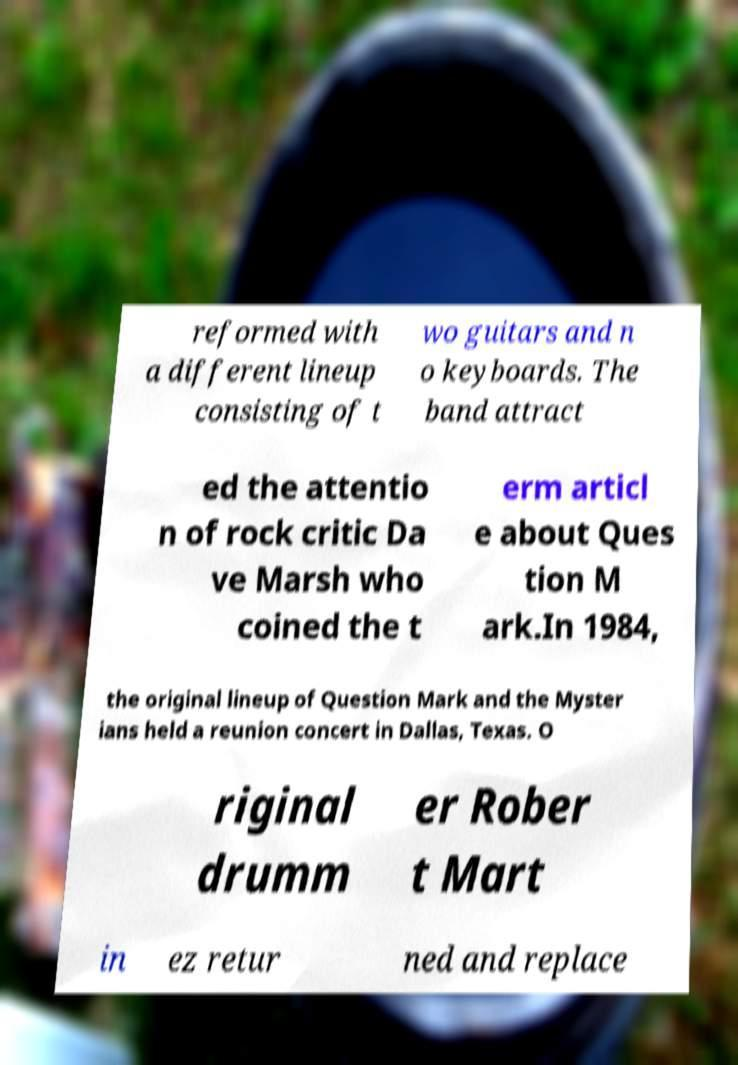I need the written content from this picture converted into text. Can you do that? reformed with a different lineup consisting of t wo guitars and n o keyboards. The band attract ed the attentio n of rock critic Da ve Marsh who coined the t erm articl e about Ques tion M ark.In 1984, the original lineup of Question Mark and the Myster ians held a reunion concert in Dallas, Texas. O riginal drumm er Rober t Mart in ez retur ned and replace 